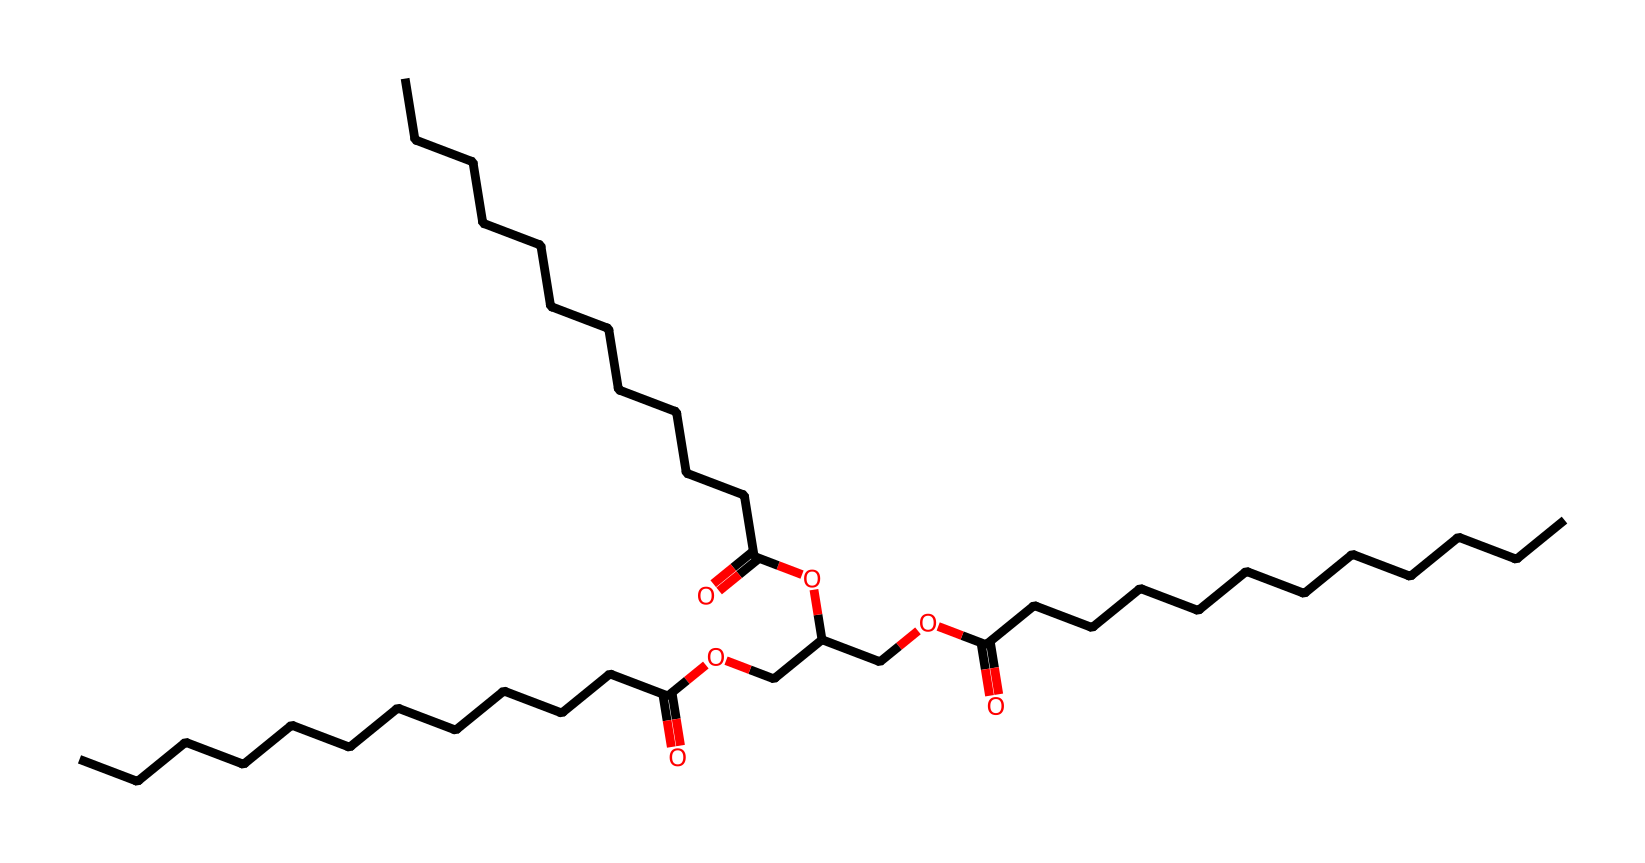What is the total number of carbon atoms in this molecule? In the SMILES representation, we can count the number of 'C' characters. The molecule consists of several repeating carbon chains and some in functional groups. By counting carefully, we find there are 36 carbon atoms.
Answer: 36 How many ester functional groups are present in this molecular structure? By examining the structure in the SMILES, we can identify ester functional groups indicated by the presence of -O- in connection with carbonyl (-C(=O)-) groups. There are three such connections in the molecule, indicating three ester functional groups.
Answer: 3 What type of functional groups are present within this molecule? Looking at the SMILES, we can identify carboxylic acid (due to -C(=O)OH) and ester groups (due to -O-C(=O)-) as the main functional groups present. Both are prominent in the structure, but we focus on their essence as a functional group category.
Answer: carboxylic acid and ester Which part of this molecule primarily influences its moisturizing properties? The presence of long-chain fatty acids and the esters in the structure tend to retain moisture, enhancing the oil's lubricating properties on the skin. This characteristic is derived from the fatty acid chains (indicated by numerous carbon chains).
Answer: fatty acid chains What does the arrangement of carbon chains signify regarding the oil's texture? The long carbon chains contribute to a smooth, oily texture, which is characteristic of emollients. More specifically, the linear structure allows better spreading over the skin, leading to a velvety feel.
Answer: smooth, oily texture What is the relationship between its molecular structure and its use in beauty products? The structure shows a combination of fatty acids and esters, meaning it has both moisturizing and skin-nourishing properties. The long carbon chains provide a stable formulation ideal for beauty products, ensuring skin hydration.
Answer: moisturizing and skin-nourishing properties 